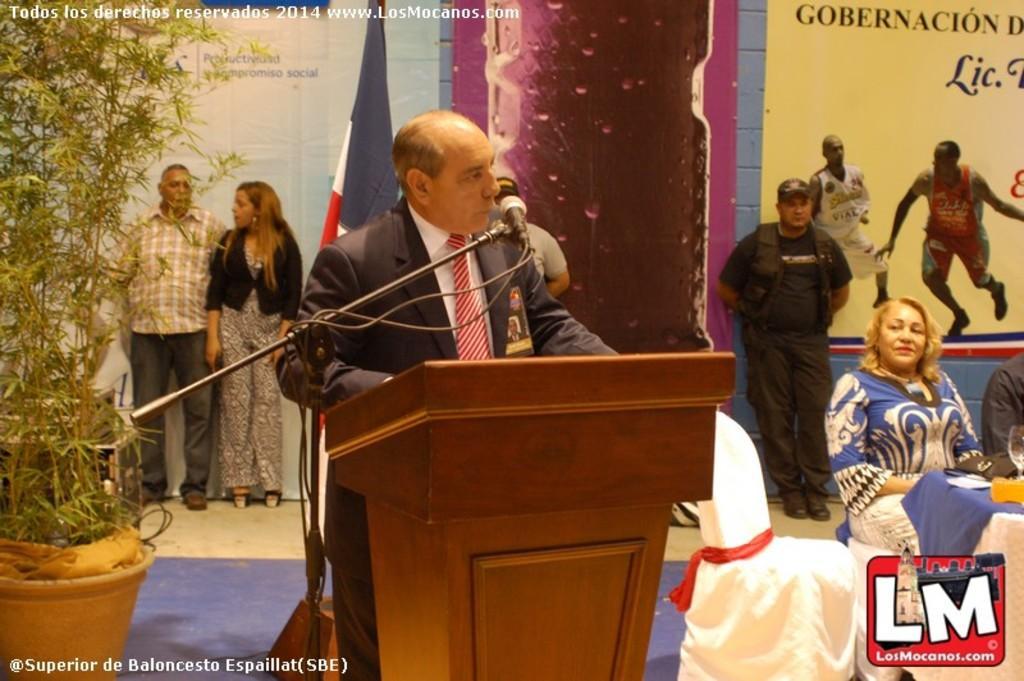Describe this image in one or two sentences. In this image we can see a man behind the podium. In front of him there is a microphone and a stand. Behind the man there are some people and banners. On the left side of the image there are plants in pots. On the image there are watermarks. At the bottom right corner of the image there is a logo. 